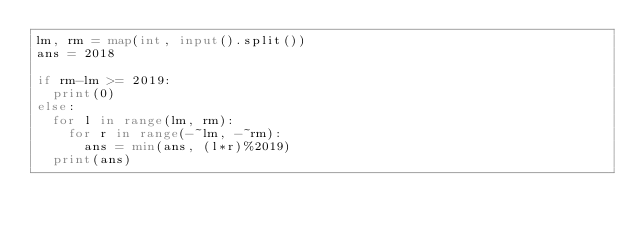<code> <loc_0><loc_0><loc_500><loc_500><_Python_>lm, rm = map(int, input().split())
ans = 2018

if rm-lm >= 2019:
  print(0)
else:
  for l in range(lm, rm):
    for r in range(-~lm, -~rm):
      ans = min(ans, (l*r)%2019)
  print(ans)</code> 